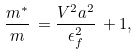<formula> <loc_0><loc_0><loc_500><loc_500>\frac { m ^ { * } } { m } \, = \frac { V ^ { 2 } a ^ { 2 } } { \epsilon _ { f } ^ { 2 } } \, + 1 ,</formula> 